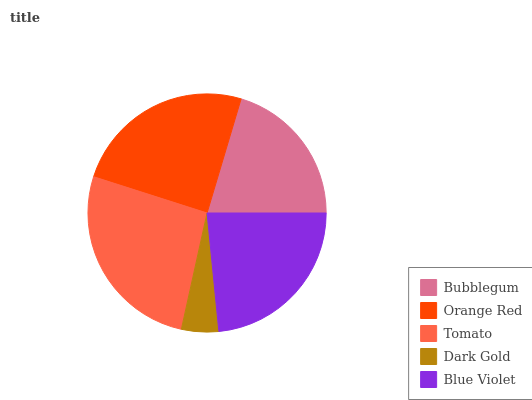Is Dark Gold the minimum?
Answer yes or no. Yes. Is Tomato the maximum?
Answer yes or no. Yes. Is Orange Red the minimum?
Answer yes or no. No. Is Orange Red the maximum?
Answer yes or no. No. Is Orange Red greater than Bubblegum?
Answer yes or no. Yes. Is Bubblegum less than Orange Red?
Answer yes or no. Yes. Is Bubblegum greater than Orange Red?
Answer yes or no. No. Is Orange Red less than Bubblegum?
Answer yes or no. No. Is Blue Violet the high median?
Answer yes or no. Yes. Is Blue Violet the low median?
Answer yes or no. Yes. Is Orange Red the high median?
Answer yes or no. No. Is Bubblegum the low median?
Answer yes or no. No. 